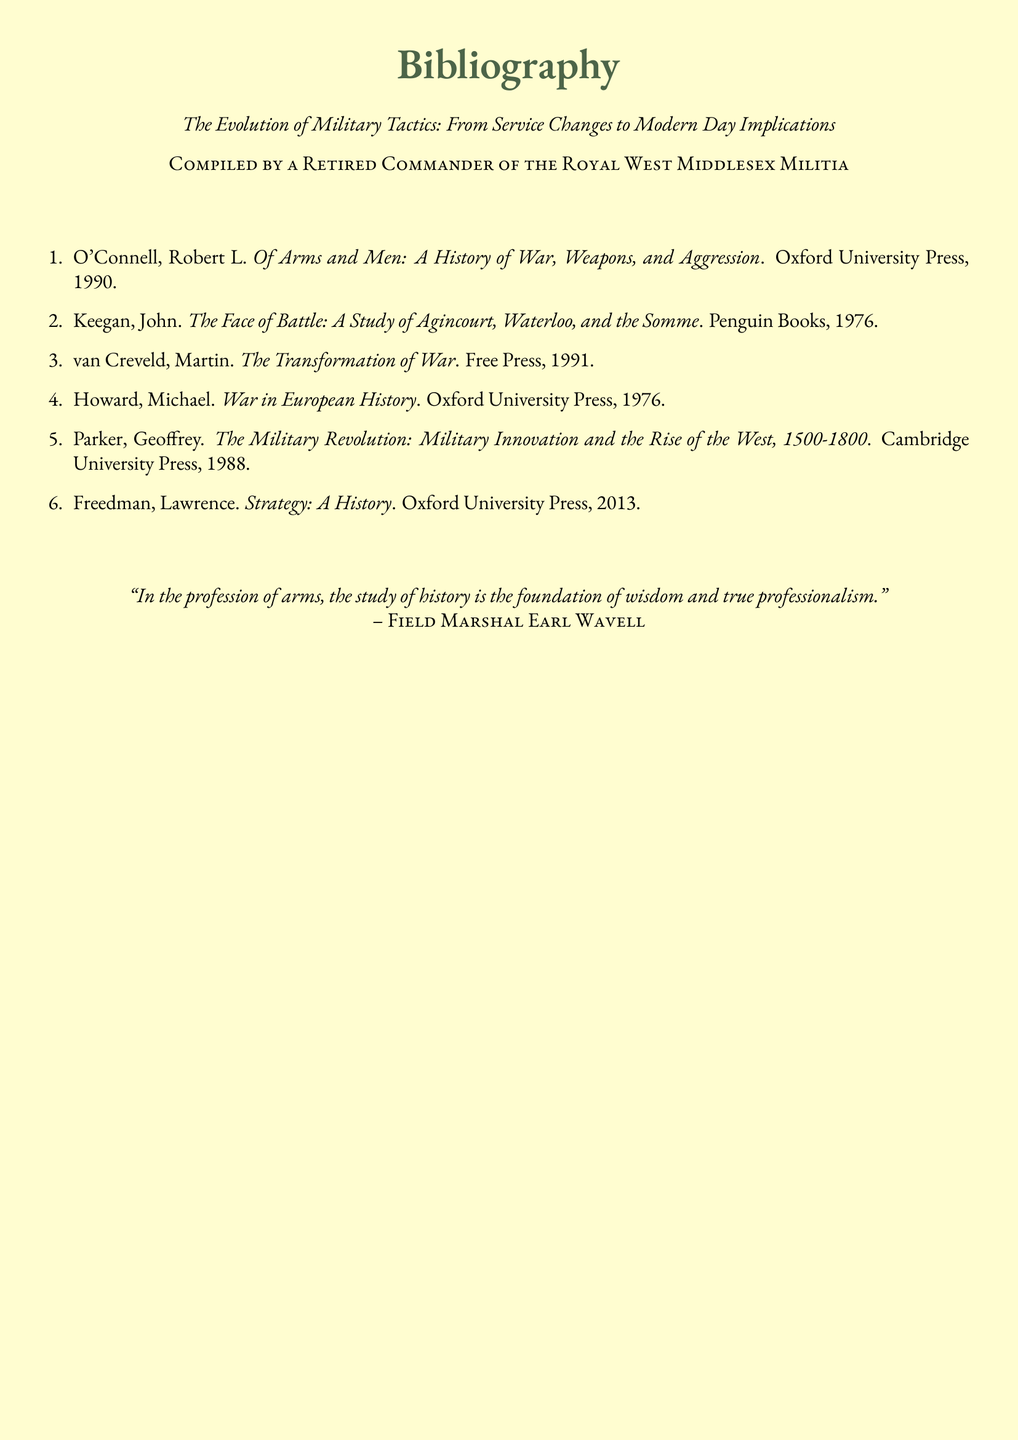What is the title of the document? The title of the document is clearly stated at the top, which reflects its content.
Answer: The Evolution of Military Tactics: From Service Changes to Modern Day Implications Who compiled the bibliography? The document indicates who compiled it, providing a clear authorship.
Answer: A Retired Commander of the Royal West Middlesex Militia What is the first book listed in the bibliography? The first entry in the enumerated list of the bibliography provides this information.
Answer: Of Arms and Men: A History of War, Weapons, and Aggression How many books are included in the bibliography? The total number of entries in the bibliography gives us this number.
Answer: Six Who is the author of 'The Face of Battle'? The second book in the list provides the author's name directly associated with it.
Answer: John Keegan What year was 'Strategy: A History' published? The publication year is included as part of the citation for the last book in the list.
Answer: 2013 Which publisher released 'The Military Revolution'? The publisher is mentioned in the citation of the fifth book, giving us the required information.
Answer: Cambridge University Press What is the color scheme of the document background? The document's formatting descriptions indicate its color features.
Answer: Parchment 